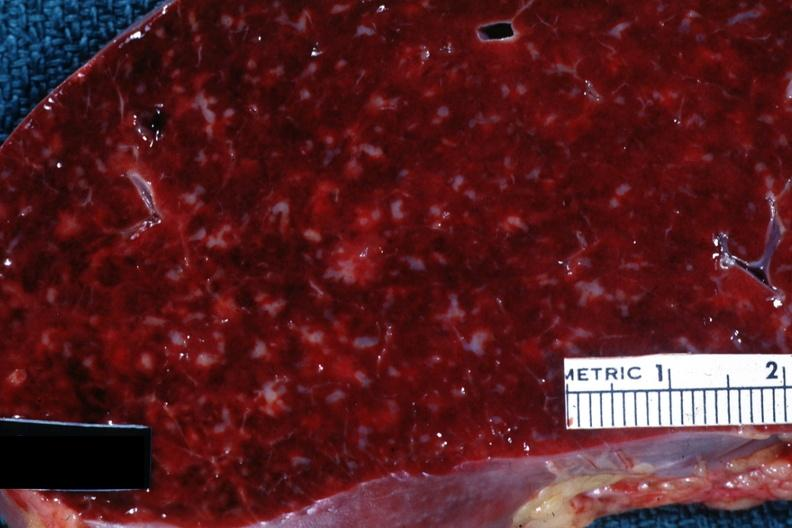what is present?
Answer the question using a single word or phrase. Hematologic 